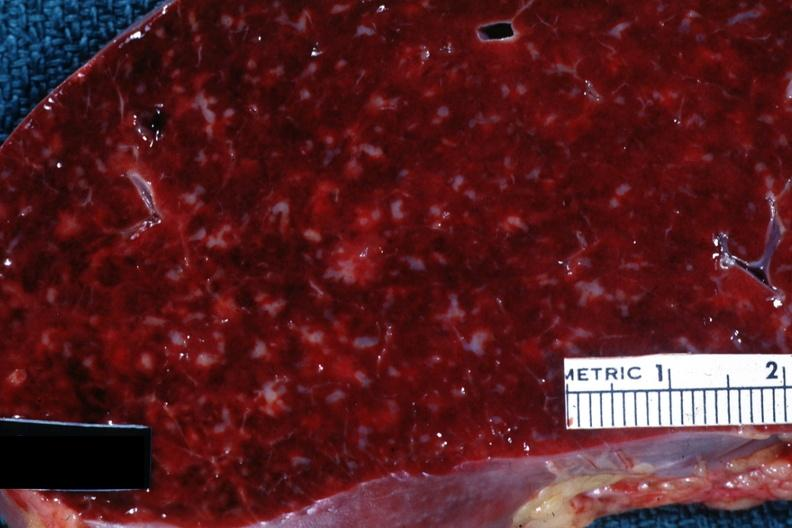what is present?
Answer the question using a single word or phrase. Hematologic 